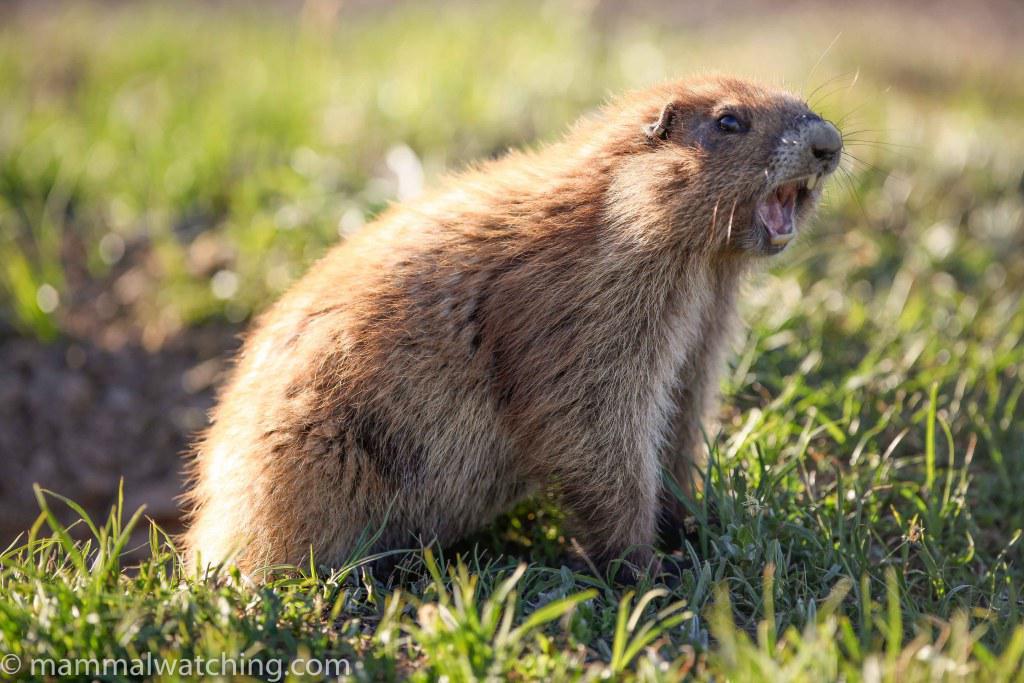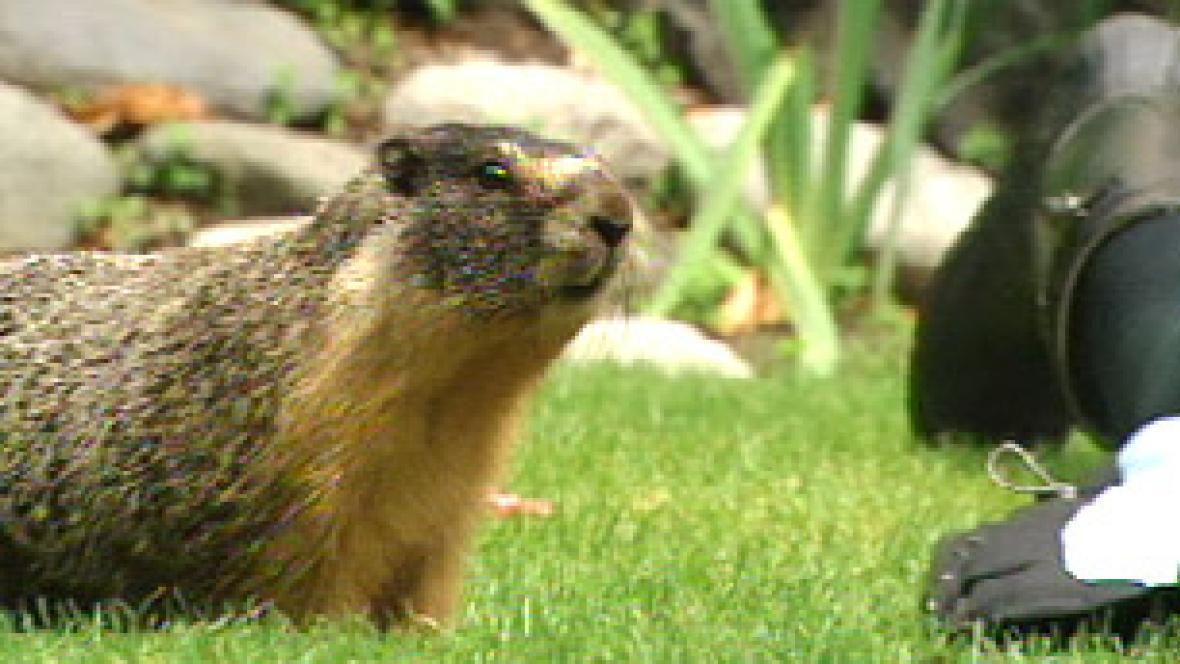The first image is the image on the left, the second image is the image on the right. Considering the images on both sides, is "the creature in the left image has its mouth wide open" valid? Answer yes or no. Yes. The first image is the image on the left, the second image is the image on the right. Analyze the images presented: Is the assertion "There are green fields in both of them." valid? Answer yes or no. Yes. 